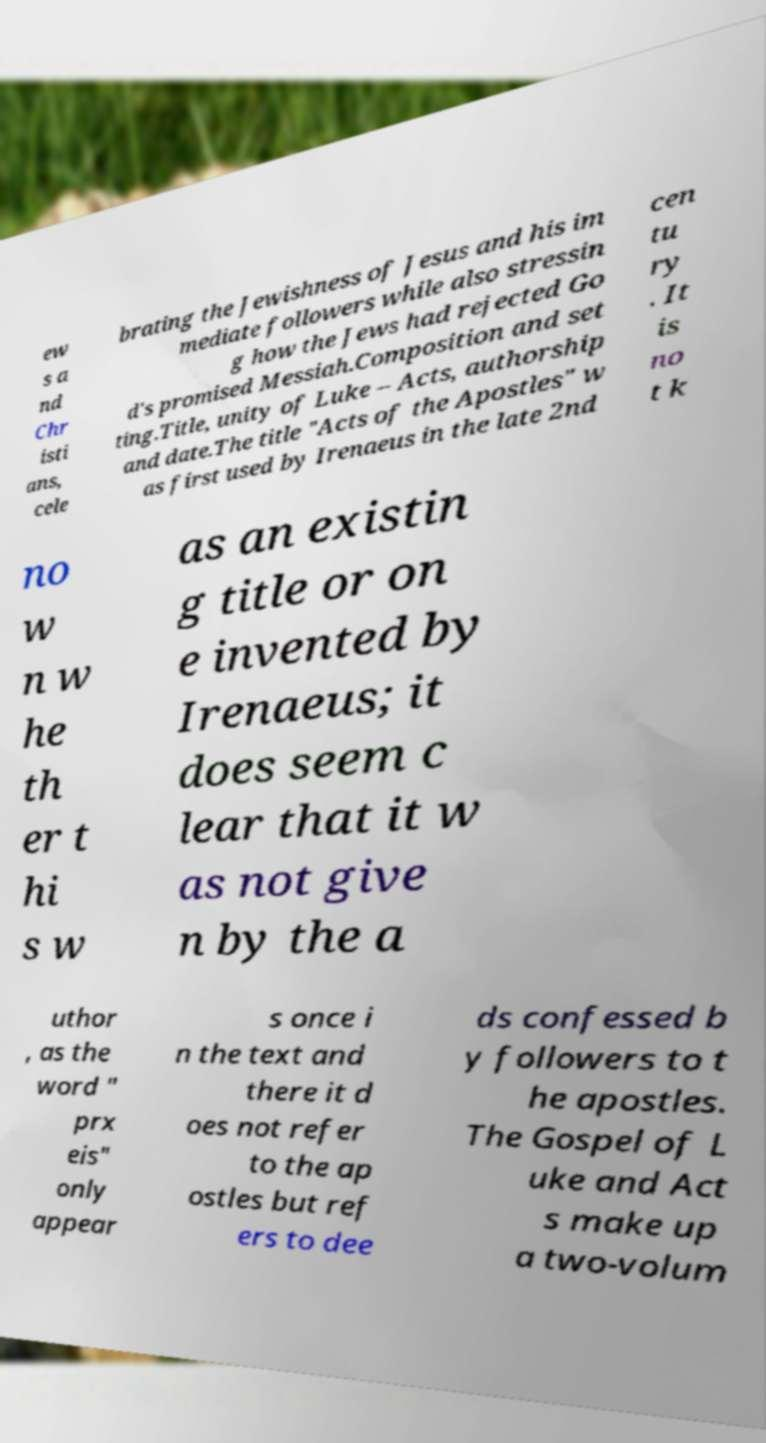There's text embedded in this image that I need extracted. Can you transcribe it verbatim? ew s a nd Chr isti ans, cele brating the Jewishness of Jesus and his im mediate followers while also stressin g how the Jews had rejected Go d's promised Messiah.Composition and set ting.Title, unity of Luke – Acts, authorship and date.The title "Acts of the Apostles" w as first used by Irenaeus in the late 2nd cen tu ry . It is no t k no w n w he th er t hi s w as an existin g title or on e invented by Irenaeus; it does seem c lear that it w as not give n by the a uthor , as the word " prx eis" only appear s once i n the text and there it d oes not refer to the ap ostles but ref ers to dee ds confessed b y followers to t he apostles. The Gospel of L uke and Act s make up a two-volum 